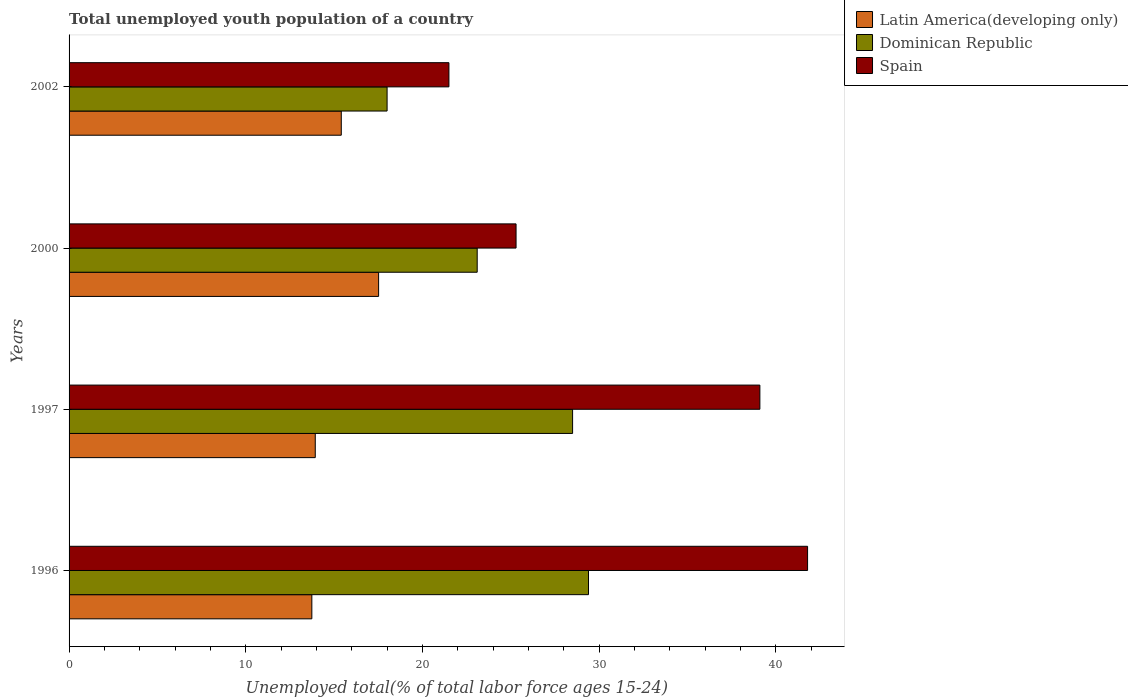How many different coloured bars are there?
Give a very brief answer. 3. Are the number of bars per tick equal to the number of legend labels?
Offer a terse response. Yes. Are the number of bars on each tick of the Y-axis equal?
Provide a succinct answer. Yes. How many bars are there on the 4th tick from the bottom?
Your answer should be compact. 3. What is the label of the 2nd group of bars from the top?
Provide a short and direct response. 2000. What is the percentage of total unemployed youth population of a country in Latin America(developing only) in 2000?
Your answer should be very brief. 17.52. Across all years, what is the maximum percentage of total unemployed youth population of a country in Latin America(developing only)?
Your answer should be very brief. 17.52. Across all years, what is the minimum percentage of total unemployed youth population of a country in Dominican Republic?
Your answer should be very brief. 18. In which year was the percentage of total unemployed youth population of a country in Latin America(developing only) minimum?
Offer a terse response. 1996. What is the total percentage of total unemployed youth population of a country in Dominican Republic in the graph?
Provide a succinct answer. 99. What is the difference between the percentage of total unemployed youth population of a country in Spain in 1997 and that in 2000?
Give a very brief answer. 13.8. What is the difference between the percentage of total unemployed youth population of a country in Spain in 2000 and the percentage of total unemployed youth population of a country in Dominican Republic in 2002?
Ensure brevity in your answer.  7.3. What is the average percentage of total unemployed youth population of a country in Dominican Republic per year?
Your answer should be compact. 24.75. In the year 2000, what is the difference between the percentage of total unemployed youth population of a country in Spain and percentage of total unemployed youth population of a country in Latin America(developing only)?
Your answer should be compact. 7.78. In how many years, is the percentage of total unemployed youth population of a country in Spain greater than 4 %?
Your answer should be compact. 4. What is the ratio of the percentage of total unemployed youth population of a country in Spain in 1996 to that in 2000?
Give a very brief answer. 1.65. Is the percentage of total unemployed youth population of a country in Spain in 1997 less than that in 2000?
Offer a very short reply. No. Is the difference between the percentage of total unemployed youth population of a country in Spain in 1997 and 2000 greater than the difference between the percentage of total unemployed youth population of a country in Latin America(developing only) in 1997 and 2000?
Offer a terse response. Yes. What is the difference between the highest and the second highest percentage of total unemployed youth population of a country in Dominican Republic?
Your response must be concise. 0.9. What is the difference between the highest and the lowest percentage of total unemployed youth population of a country in Dominican Republic?
Your response must be concise. 11.4. In how many years, is the percentage of total unemployed youth population of a country in Latin America(developing only) greater than the average percentage of total unemployed youth population of a country in Latin America(developing only) taken over all years?
Your response must be concise. 2. Is the sum of the percentage of total unemployed youth population of a country in Latin America(developing only) in 1996 and 2002 greater than the maximum percentage of total unemployed youth population of a country in Spain across all years?
Your answer should be compact. No. What does the 2nd bar from the top in 2002 represents?
Give a very brief answer. Dominican Republic. What does the 2nd bar from the bottom in 1996 represents?
Offer a very short reply. Dominican Republic. Is it the case that in every year, the sum of the percentage of total unemployed youth population of a country in Dominican Republic and percentage of total unemployed youth population of a country in Latin America(developing only) is greater than the percentage of total unemployed youth population of a country in Spain?
Your answer should be compact. Yes. How many years are there in the graph?
Offer a very short reply. 4. Does the graph contain grids?
Your answer should be very brief. No. Where does the legend appear in the graph?
Give a very brief answer. Top right. How many legend labels are there?
Keep it short and to the point. 3. What is the title of the graph?
Give a very brief answer. Total unemployed youth population of a country. What is the label or title of the X-axis?
Offer a very short reply. Unemployed total(% of total labor force ages 15-24). What is the label or title of the Y-axis?
Provide a succinct answer. Years. What is the Unemployed total(% of total labor force ages 15-24) in Latin America(developing only) in 1996?
Offer a terse response. 13.74. What is the Unemployed total(% of total labor force ages 15-24) of Dominican Republic in 1996?
Provide a short and direct response. 29.4. What is the Unemployed total(% of total labor force ages 15-24) in Spain in 1996?
Provide a succinct answer. 41.8. What is the Unemployed total(% of total labor force ages 15-24) of Latin America(developing only) in 1997?
Your response must be concise. 13.93. What is the Unemployed total(% of total labor force ages 15-24) in Dominican Republic in 1997?
Ensure brevity in your answer.  28.5. What is the Unemployed total(% of total labor force ages 15-24) of Spain in 1997?
Offer a terse response. 39.1. What is the Unemployed total(% of total labor force ages 15-24) of Latin America(developing only) in 2000?
Your answer should be compact. 17.52. What is the Unemployed total(% of total labor force ages 15-24) of Dominican Republic in 2000?
Make the answer very short. 23.1. What is the Unemployed total(% of total labor force ages 15-24) in Spain in 2000?
Provide a short and direct response. 25.3. What is the Unemployed total(% of total labor force ages 15-24) in Latin America(developing only) in 2002?
Make the answer very short. 15.41. Across all years, what is the maximum Unemployed total(% of total labor force ages 15-24) in Latin America(developing only)?
Give a very brief answer. 17.52. Across all years, what is the maximum Unemployed total(% of total labor force ages 15-24) of Dominican Republic?
Offer a very short reply. 29.4. Across all years, what is the maximum Unemployed total(% of total labor force ages 15-24) in Spain?
Offer a very short reply. 41.8. Across all years, what is the minimum Unemployed total(% of total labor force ages 15-24) of Latin America(developing only)?
Your answer should be very brief. 13.74. Across all years, what is the minimum Unemployed total(% of total labor force ages 15-24) in Dominican Republic?
Your answer should be very brief. 18. What is the total Unemployed total(% of total labor force ages 15-24) in Latin America(developing only) in the graph?
Your answer should be very brief. 60.6. What is the total Unemployed total(% of total labor force ages 15-24) of Dominican Republic in the graph?
Your answer should be very brief. 99. What is the total Unemployed total(% of total labor force ages 15-24) in Spain in the graph?
Your response must be concise. 127.7. What is the difference between the Unemployed total(% of total labor force ages 15-24) in Latin America(developing only) in 1996 and that in 1997?
Your response must be concise. -0.19. What is the difference between the Unemployed total(% of total labor force ages 15-24) in Latin America(developing only) in 1996 and that in 2000?
Ensure brevity in your answer.  -3.78. What is the difference between the Unemployed total(% of total labor force ages 15-24) in Latin America(developing only) in 1996 and that in 2002?
Offer a terse response. -1.67. What is the difference between the Unemployed total(% of total labor force ages 15-24) of Spain in 1996 and that in 2002?
Make the answer very short. 20.3. What is the difference between the Unemployed total(% of total labor force ages 15-24) of Latin America(developing only) in 1997 and that in 2000?
Make the answer very short. -3.59. What is the difference between the Unemployed total(% of total labor force ages 15-24) in Latin America(developing only) in 1997 and that in 2002?
Offer a terse response. -1.47. What is the difference between the Unemployed total(% of total labor force ages 15-24) of Dominican Republic in 1997 and that in 2002?
Provide a succinct answer. 10.5. What is the difference between the Unemployed total(% of total labor force ages 15-24) in Spain in 1997 and that in 2002?
Your response must be concise. 17.6. What is the difference between the Unemployed total(% of total labor force ages 15-24) of Latin America(developing only) in 2000 and that in 2002?
Offer a very short reply. 2.11. What is the difference between the Unemployed total(% of total labor force ages 15-24) of Spain in 2000 and that in 2002?
Your answer should be very brief. 3.8. What is the difference between the Unemployed total(% of total labor force ages 15-24) in Latin America(developing only) in 1996 and the Unemployed total(% of total labor force ages 15-24) in Dominican Republic in 1997?
Make the answer very short. -14.76. What is the difference between the Unemployed total(% of total labor force ages 15-24) of Latin America(developing only) in 1996 and the Unemployed total(% of total labor force ages 15-24) of Spain in 1997?
Provide a short and direct response. -25.36. What is the difference between the Unemployed total(% of total labor force ages 15-24) in Latin America(developing only) in 1996 and the Unemployed total(% of total labor force ages 15-24) in Dominican Republic in 2000?
Ensure brevity in your answer.  -9.36. What is the difference between the Unemployed total(% of total labor force ages 15-24) of Latin America(developing only) in 1996 and the Unemployed total(% of total labor force ages 15-24) of Spain in 2000?
Offer a very short reply. -11.56. What is the difference between the Unemployed total(% of total labor force ages 15-24) of Latin America(developing only) in 1996 and the Unemployed total(% of total labor force ages 15-24) of Dominican Republic in 2002?
Provide a succinct answer. -4.26. What is the difference between the Unemployed total(% of total labor force ages 15-24) in Latin America(developing only) in 1996 and the Unemployed total(% of total labor force ages 15-24) in Spain in 2002?
Provide a short and direct response. -7.76. What is the difference between the Unemployed total(% of total labor force ages 15-24) in Latin America(developing only) in 1997 and the Unemployed total(% of total labor force ages 15-24) in Dominican Republic in 2000?
Offer a very short reply. -9.17. What is the difference between the Unemployed total(% of total labor force ages 15-24) of Latin America(developing only) in 1997 and the Unemployed total(% of total labor force ages 15-24) of Spain in 2000?
Your response must be concise. -11.37. What is the difference between the Unemployed total(% of total labor force ages 15-24) in Latin America(developing only) in 1997 and the Unemployed total(% of total labor force ages 15-24) in Dominican Republic in 2002?
Make the answer very short. -4.07. What is the difference between the Unemployed total(% of total labor force ages 15-24) of Latin America(developing only) in 1997 and the Unemployed total(% of total labor force ages 15-24) of Spain in 2002?
Give a very brief answer. -7.57. What is the difference between the Unemployed total(% of total labor force ages 15-24) in Latin America(developing only) in 2000 and the Unemployed total(% of total labor force ages 15-24) in Dominican Republic in 2002?
Your response must be concise. -0.48. What is the difference between the Unemployed total(% of total labor force ages 15-24) in Latin America(developing only) in 2000 and the Unemployed total(% of total labor force ages 15-24) in Spain in 2002?
Give a very brief answer. -3.98. What is the average Unemployed total(% of total labor force ages 15-24) in Latin America(developing only) per year?
Make the answer very short. 15.15. What is the average Unemployed total(% of total labor force ages 15-24) in Dominican Republic per year?
Your answer should be compact. 24.75. What is the average Unemployed total(% of total labor force ages 15-24) in Spain per year?
Your answer should be compact. 31.93. In the year 1996, what is the difference between the Unemployed total(% of total labor force ages 15-24) in Latin America(developing only) and Unemployed total(% of total labor force ages 15-24) in Dominican Republic?
Make the answer very short. -15.66. In the year 1996, what is the difference between the Unemployed total(% of total labor force ages 15-24) of Latin America(developing only) and Unemployed total(% of total labor force ages 15-24) of Spain?
Offer a terse response. -28.06. In the year 1997, what is the difference between the Unemployed total(% of total labor force ages 15-24) in Latin America(developing only) and Unemployed total(% of total labor force ages 15-24) in Dominican Republic?
Your response must be concise. -14.57. In the year 1997, what is the difference between the Unemployed total(% of total labor force ages 15-24) in Latin America(developing only) and Unemployed total(% of total labor force ages 15-24) in Spain?
Offer a very short reply. -25.17. In the year 1997, what is the difference between the Unemployed total(% of total labor force ages 15-24) of Dominican Republic and Unemployed total(% of total labor force ages 15-24) of Spain?
Your answer should be very brief. -10.6. In the year 2000, what is the difference between the Unemployed total(% of total labor force ages 15-24) in Latin America(developing only) and Unemployed total(% of total labor force ages 15-24) in Dominican Republic?
Your answer should be very brief. -5.58. In the year 2000, what is the difference between the Unemployed total(% of total labor force ages 15-24) in Latin America(developing only) and Unemployed total(% of total labor force ages 15-24) in Spain?
Offer a very short reply. -7.78. In the year 2002, what is the difference between the Unemployed total(% of total labor force ages 15-24) in Latin America(developing only) and Unemployed total(% of total labor force ages 15-24) in Dominican Republic?
Offer a terse response. -2.59. In the year 2002, what is the difference between the Unemployed total(% of total labor force ages 15-24) in Latin America(developing only) and Unemployed total(% of total labor force ages 15-24) in Spain?
Your answer should be compact. -6.09. In the year 2002, what is the difference between the Unemployed total(% of total labor force ages 15-24) of Dominican Republic and Unemployed total(% of total labor force ages 15-24) of Spain?
Your answer should be compact. -3.5. What is the ratio of the Unemployed total(% of total labor force ages 15-24) in Latin America(developing only) in 1996 to that in 1997?
Provide a short and direct response. 0.99. What is the ratio of the Unemployed total(% of total labor force ages 15-24) in Dominican Republic in 1996 to that in 1997?
Make the answer very short. 1.03. What is the ratio of the Unemployed total(% of total labor force ages 15-24) of Spain in 1996 to that in 1997?
Your response must be concise. 1.07. What is the ratio of the Unemployed total(% of total labor force ages 15-24) in Latin America(developing only) in 1996 to that in 2000?
Make the answer very short. 0.78. What is the ratio of the Unemployed total(% of total labor force ages 15-24) of Dominican Republic in 1996 to that in 2000?
Give a very brief answer. 1.27. What is the ratio of the Unemployed total(% of total labor force ages 15-24) of Spain in 1996 to that in 2000?
Provide a succinct answer. 1.65. What is the ratio of the Unemployed total(% of total labor force ages 15-24) in Latin America(developing only) in 1996 to that in 2002?
Offer a very short reply. 0.89. What is the ratio of the Unemployed total(% of total labor force ages 15-24) of Dominican Republic in 1996 to that in 2002?
Offer a terse response. 1.63. What is the ratio of the Unemployed total(% of total labor force ages 15-24) in Spain in 1996 to that in 2002?
Keep it short and to the point. 1.94. What is the ratio of the Unemployed total(% of total labor force ages 15-24) in Latin America(developing only) in 1997 to that in 2000?
Provide a succinct answer. 0.8. What is the ratio of the Unemployed total(% of total labor force ages 15-24) of Dominican Republic in 1997 to that in 2000?
Provide a succinct answer. 1.23. What is the ratio of the Unemployed total(% of total labor force ages 15-24) of Spain in 1997 to that in 2000?
Your response must be concise. 1.55. What is the ratio of the Unemployed total(% of total labor force ages 15-24) of Latin America(developing only) in 1997 to that in 2002?
Make the answer very short. 0.9. What is the ratio of the Unemployed total(% of total labor force ages 15-24) in Dominican Republic in 1997 to that in 2002?
Ensure brevity in your answer.  1.58. What is the ratio of the Unemployed total(% of total labor force ages 15-24) of Spain in 1997 to that in 2002?
Your response must be concise. 1.82. What is the ratio of the Unemployed total(% of total labor force ages 15-24) in Latin America(developing only) in 2000 to that in 2002?
Offer a very short reply. 1.14. What is the ratio of the Unemployed total(% of total labor force ages 15-24) of Dominican Republic in 2000 to that in 2002?
Your response must be concise. 1.28. What is the ratio of the Unemployed total(% of total labor force ages 15-24) of Spain in 2000 to that in 2002?
Give a very brief answer. 1.18. What is the difference between the highest and the second highest Unemployed total(% of total labor force ages 15-24) in Latin America(developing only)?
Provide a short and direct response. 2.11. What is the difference between the highest and the second highest Unemployed total(% of total labor force ages 15-24) of Spain?
Provide a short and direct response. 2.7. What is the difference between the highest and the lowest Unemployed total(% of total labor force ages 15-24) in Latin America(developing only)?
Ensure brevity in your answer.  3.78. What is the difference between the highest and the lowest Unemployed total(% of total labor force ages 15-24) in Spain?
Provide a short and direct response. 20.3. 